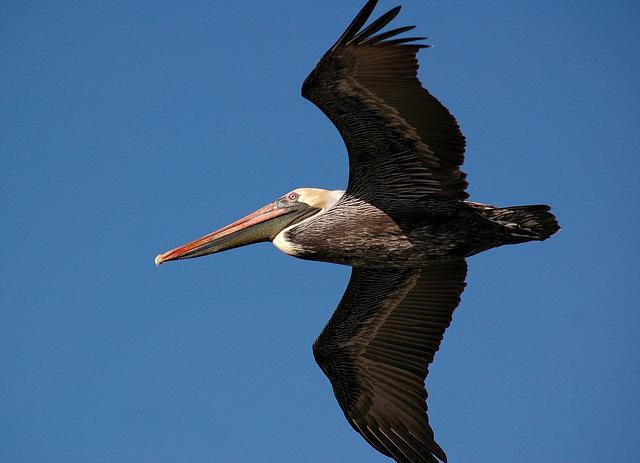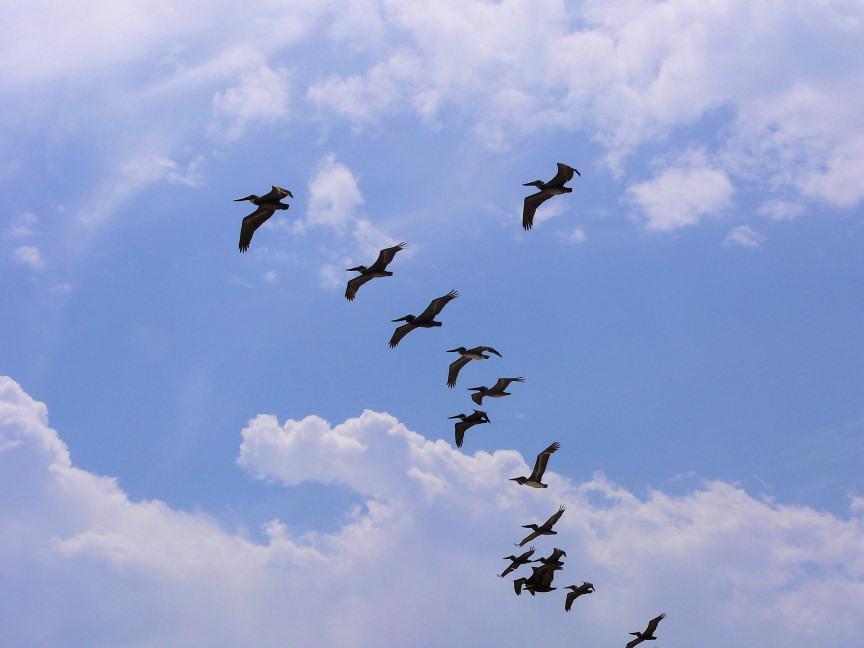The first image is the image on the left, the second image is the image on the right. Examine the images to the left and right. Is the description "A single dark pelican flying with outspread wings is in the foreground of the left image, and the right image shows at least 10 pelicans flying leftward." accurate? Answer yes or no. Yes. The first image is the image on the left, the second image is the image on the right. Given the left and right images, does the statement "A single bird is flying in the image on the left." hold true? Answer yes or no. Yes. 